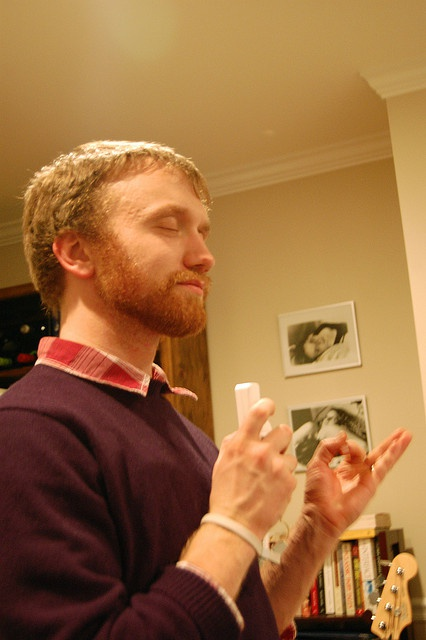Describe the objects in this image and their specific colors. I can see people in tan, black, maroon, and brown tones, book in tan and olive tones, book in tan, olive, and maroon tones, remote in tan and ivory tones, and book in tan, brown, and gray tones in this image. 